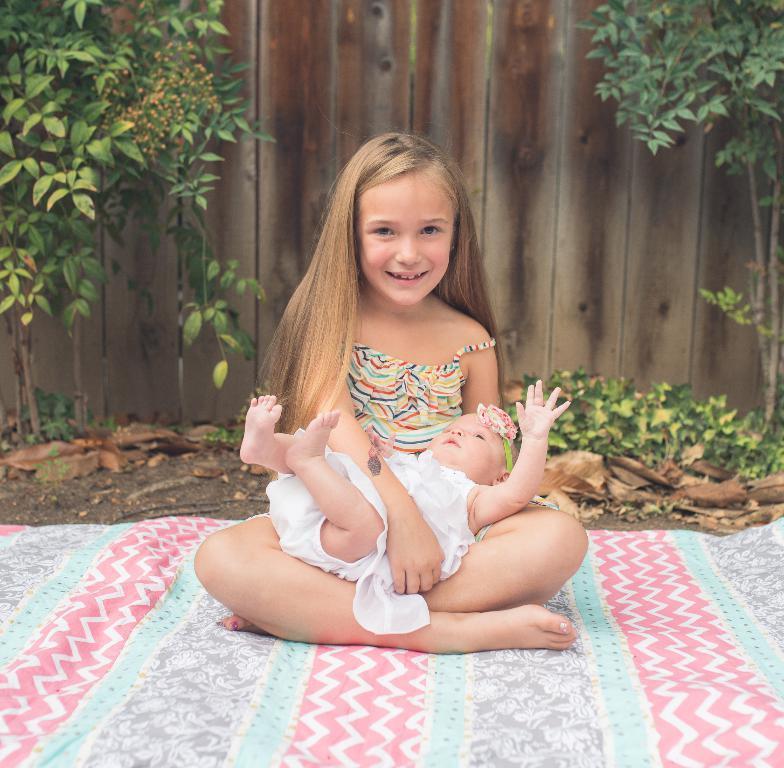Please provide a concise description of this image. In the center of the image there is a girl holding a baby. At the bottom of the image we can see bed sheet. In the background we can see trees, plants and wooden wall. 